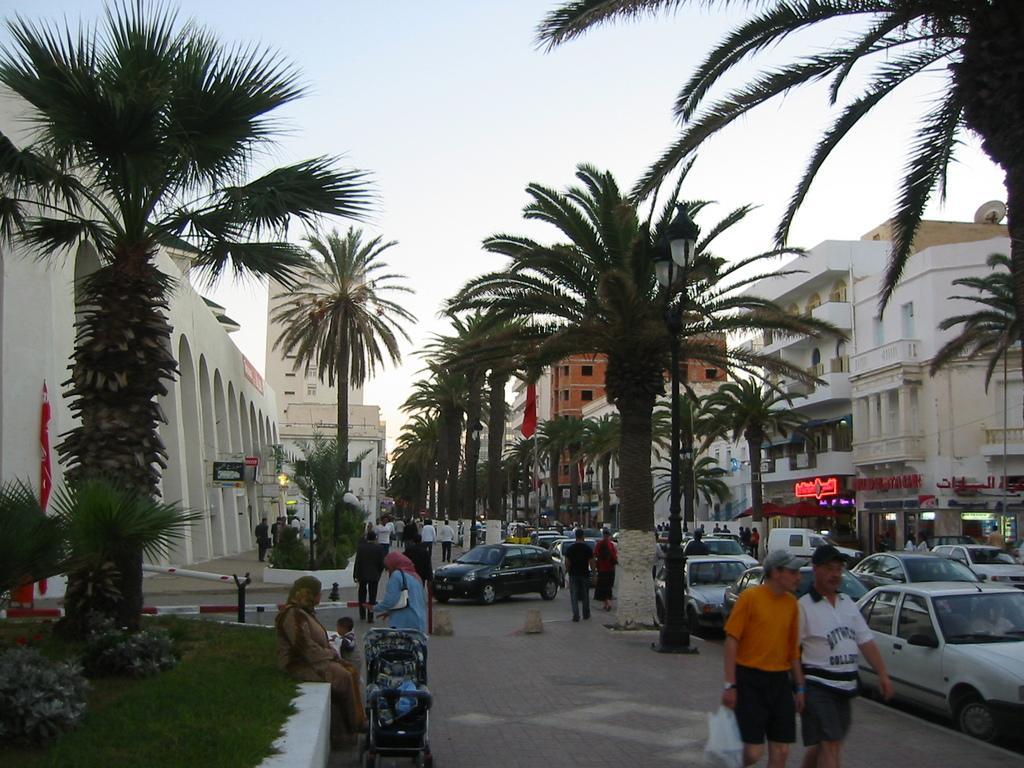Could you give a brief overview of what you see in this image? In the image we can see there are many people around, they are wearing clothes and some of them are wearing a cap. Even there are many vehicles, this is a footpath, grass, plant, tree, buildings, light pole and sky. 